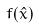Convert formula to latex. <formula><loc_0><loc_0><loc_500><loc_500>f ( \hat { x } )</formula> 